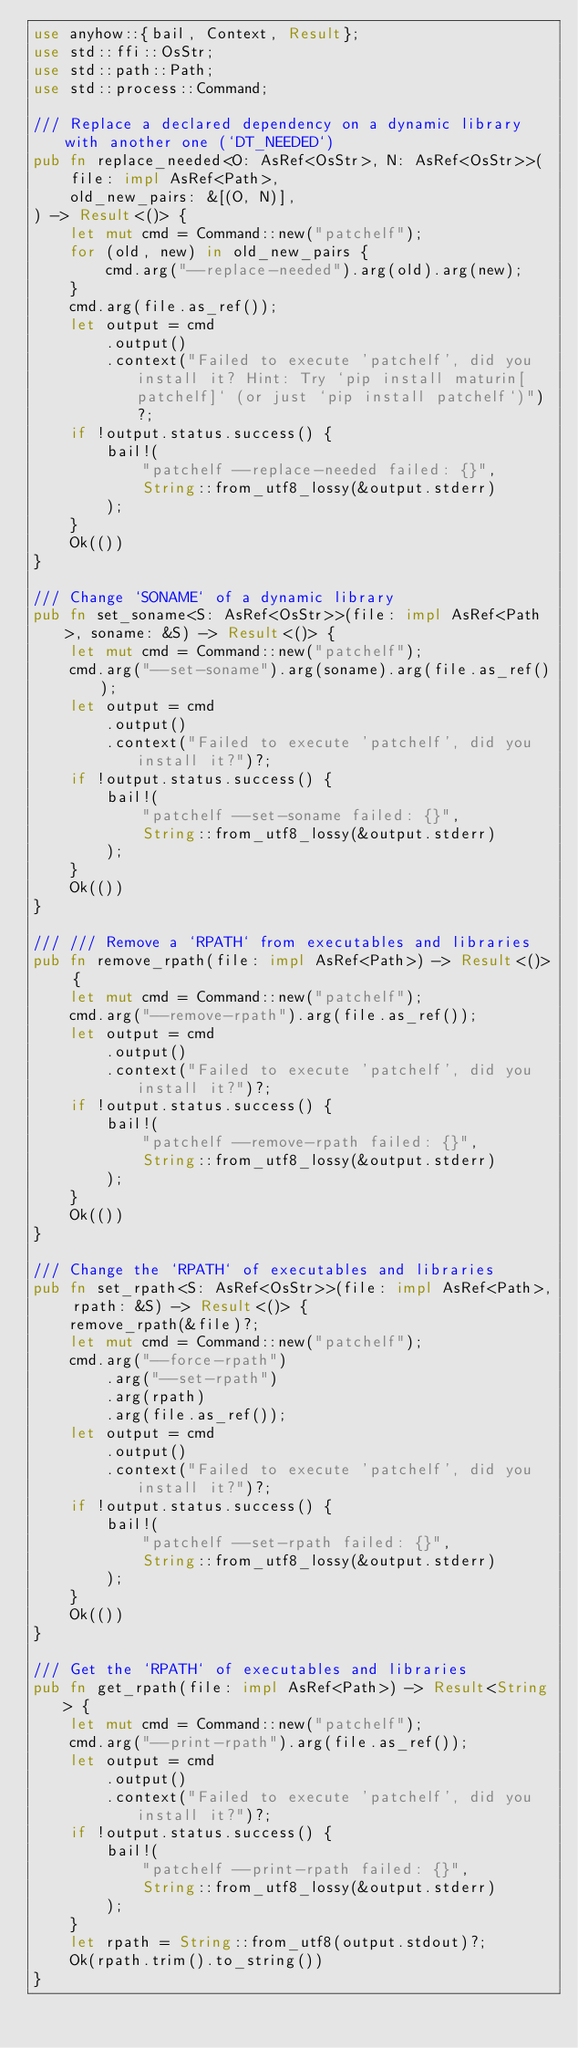Convert code to text. <code><loc_0><loc_0><loc_500><loc_500><_Rust_>use anyhow::{bail, Context, Result};
use std::ffi::OsStr;
use std::path::Path;
use std::process::Command;

/// Replace a declared dependency on a dynamic library with another one (`DT_NEEDED`)
pub fn replace_needed<O: AsRef<OsStr>, N: AsRef<OsStr>>(
    file: impl AsRef<Path>,
    old_new_pairs: &[(O, N)],
) -> Result<()> {
    let mut cmd = Command::new("patchelf");
    for (old, new) in old_new_pairs {
        cmd.arg("--replace-needed").arg(old).arg(new);
    }
    cmd.arg(file.as_ref());
    let output = cmd
        .output()
        .context("Failed to execute 'patchelf', did you install it? Hint: Try `pip install maturin[patchelf]` (or just `pip install patchelf`)")?;
    if !output.status.success() {
        bail!(
            "patchelf --replace-needed failed: {}",
            String::from_utf8_lossy(&output.stderr)
        );
    }
    Ok(())
}

/// Change `SONAME` of a dynamic library
pub fn set_soname<S: AsRef<OsStr>>(file: impl AsRef<Path>, soname: &S) -> Result<()> {
    let mut cmd = Command::new("patchelf");
    cmd.arg("--set-soname").arg(soname).arg(file.as_ref());
    let output = cmd
        .output()
        .context("Failed to execute 'patchelf', did you install it?")?;
    if !output.status.success() {
        bail!(
            "patchelf --set-soname failed: {}",
            String::from_utf8_lossy(&output.stderr)
        );
    }
    Ok(())
}

/// /// Remove a `RPATH` from executables and libraries
pub fn remove_rpath(file: impl AsRef<Path>) -> Result<()> {
    let mut cmd = Command::new("patchelf");
    cmd.arg("--remove-rpath").arg(file.as_ref());
    let output = cmd
        .output()
        .context("Failed to execute 'patchelf', did you install it?")?;
    if !output.status.success() {
        bail!(
            "patchelf --remove-rpath failed: {}",
            String::from_utf8_lossy(&output.stderr)
        );
    }
    Ok(())
}

/// Change the `RPATH` of executables and libraries
pub fn set_rpath<S: AsRef<OsStr>>(file: impl AsRef<Path>, rpath: &S) -> Result<()> {
    remove_rpath(&file)?;
    let mut cmd = Command::new("patchelf");
    cmd.arg("--force-rpath")
        .arg("--set-rpath")
        .arg(rpath)
        .arg(file.as_ref());
    let output = cmd
        .output()
        .context("Failed to execute 'patchelf', did you install it?")?;
    if !output.status.success() {
        bail!(
            "patchelf --set-rpath failed: {}",
            String::from_utf8_lossy(&output.stderr)
        );
    }
    Ok(())
}

/// Get the `RPATH` of executables and libraries
pub fn get_rpath(file: impl AsRef<Path>) -> Result<String> {
    let mut cmd = Command::new("patchelf");
    cmd.arg("--print-rpath").arg(file.as_ref());
    let output = cmd
        .output()
        .context("Failed to execute 'patchelf', did you install it?")?;
    if !output.status.success() {
        bail!(
            "patchelf --print-rpath failed: {}",
            String::from_utf8_lossy(&output.stderr)
        );
    }
    let rpath = String::from_utf8(output.stdout)?;
    Ok(rpath.trim().to_string())
}
</code> 